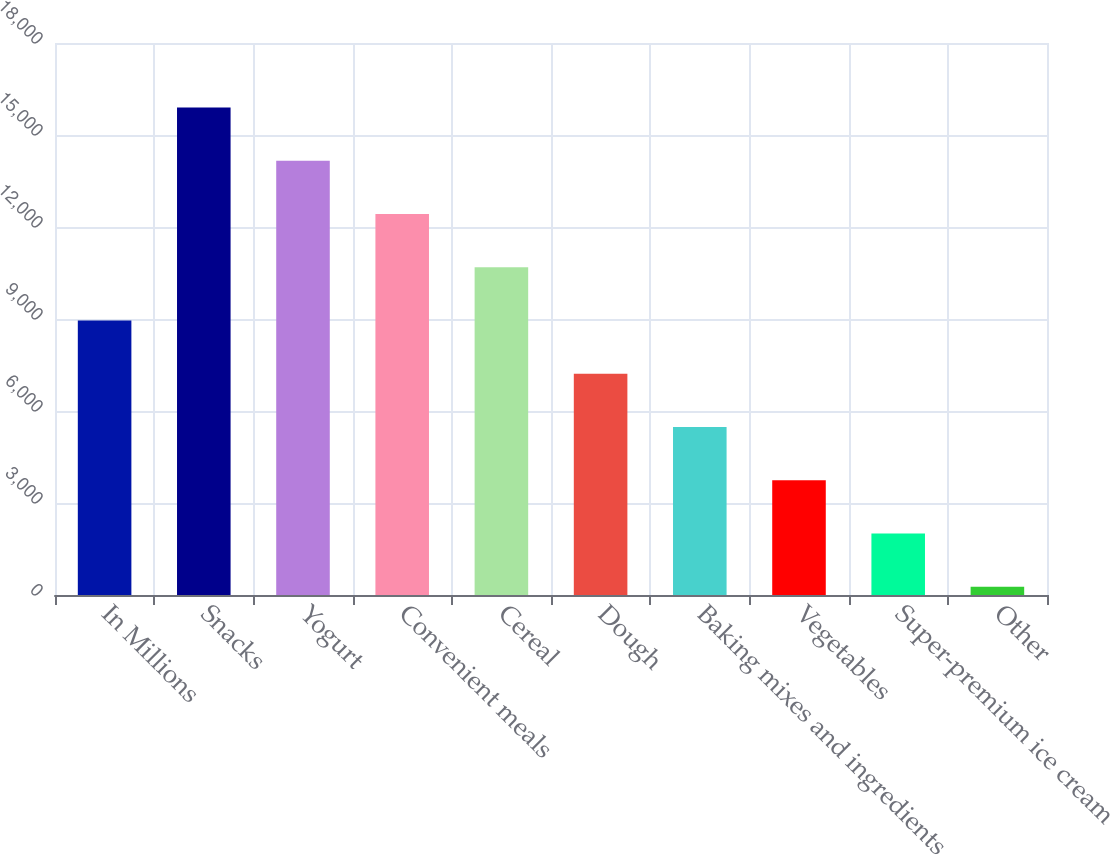Convert chart. <chart><loc_0><loc_0><loc_500><loc_500><bar_chart><fcel>In Millions<fcel>Snacks<fcel>Yogurt<fcel>Convenient meals<fcel>Cereal<fcel>Dough<fcel>Baking mixes and ingredients<fcel>Vegetables<fcel>Super-premium ice cream<fcel>Other<nl><fcel>8948.6<fcel>15894<fcel>14157.6<fcel>12421.3<fcel>10684.9<fcel>7212.26<fcel>5475.92<fcel>3739.58<fcel>2003.24<fcel>266.9<nl></chart> 